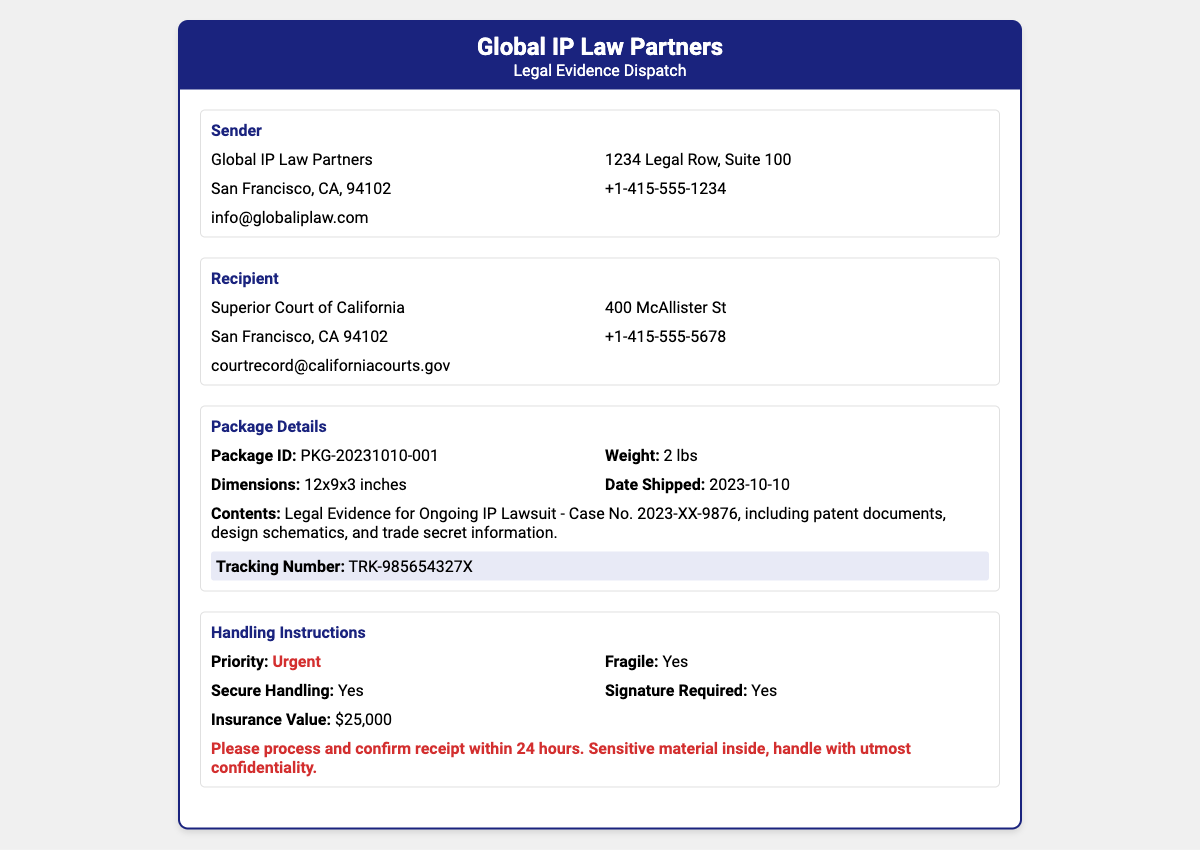What is the sender's name? The sender's name is mentioned in the document as the entity responsible for the evidence dispatch, which is Global IP Law Partners.
Answer: Global IP Law Partners What is the recipient's email address? The recipient's email address is provided in the document for contact purposes, specifically for the Superior Court of California.
Answer: courtrecord@californiacourts.gov What is the package ID? The package ID is a unique identifier provided to track this specific shipment, found under Package Details.
Answer: PKG-20231010-001 What is the weight of the package? The weight of the package is specified in the document and is important for shipping purposes.
Answer: 2 lbs What is the insurance value? The insurance value indicates the worth of the contents shipped in case of loss or damage, as outlined in the Handling Instructions.
Answer: $25,000 What is the tracking number? The tracking number is provided to monitor the shipment's progress and can be found highlighted in the document.
Answer: TRK-985654327X What should be done within 24 hours? This instruction indicates a time-sensitive action required concerning the package, providing urgency and context for handling.
Answer: Process and confirm receipt Is signature required for delivery? This question addresses whether a signature is mandated at the time of delivery, which reflects the package's importance or sensitivity.
Answer: Yes What type of material is inside the package? This question derives from the contents of the package, which gives insight into the nature of the shipment.
Answer: Legal Evidence for Ongoing IP Lawsuit 